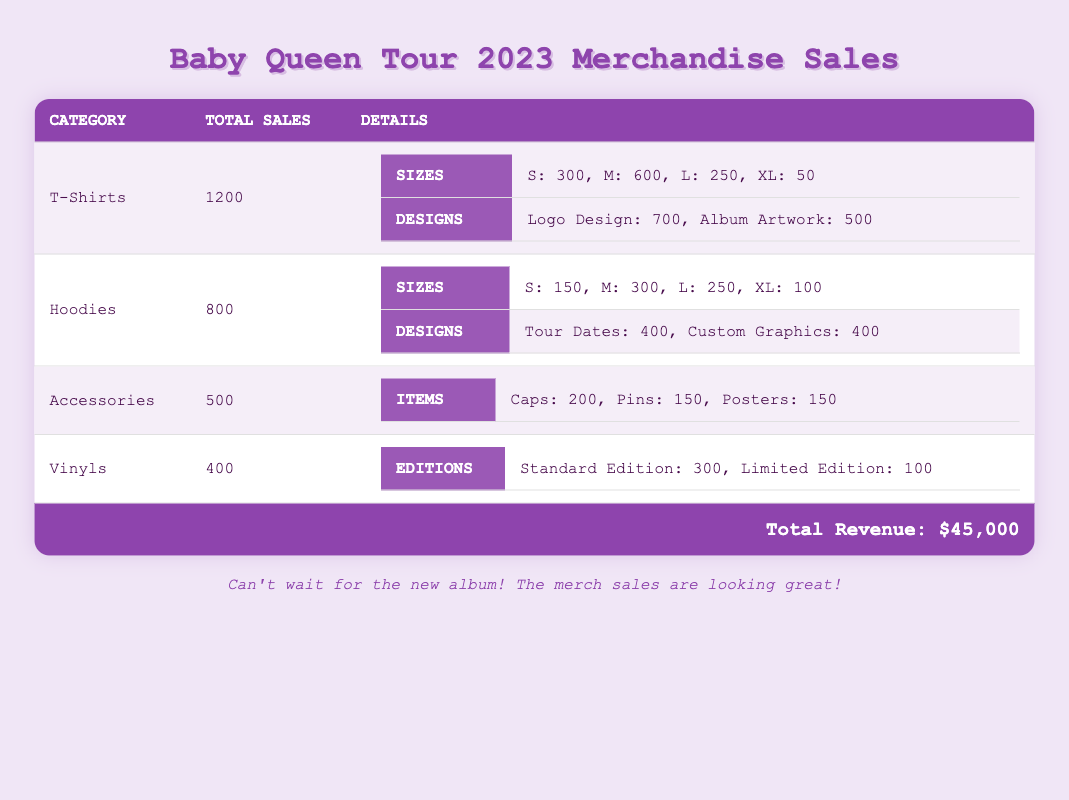What is the total number of T-Shirts sold during the Baby Queen Tour 2023? The table states that the total sales for T-Shirts is directly listed as 1200.
Answer: 1200 How many more Hoodies were sold compared to Vinyls? The total sales for Hoodies is 800 and for Vinyls is 400. The difference is calculated as 800 - 400 = 400.
Answer: 400 What size of T-Shirts had the highest sales? Looking at the breakdown of T-Shirt sizes, Medium (M) had the highest sales with 600, which is more than any other size.
Answer: Medium Is the total revenue from merchandise sales greater than $40,000? The total revenue listed is $45,000, which is indeed greater than $40,000.
Answer: Yes What is the combined number of the Custom Graphics Hoodies and the Limited Edition Vinyls sold? From the table, the number of Custom Graphics Hoodies sold is 400 and Limited Edition Vinyls is 100. Their total is 400 + 100 = 500.
Answer: 500 Which merchandise category had the least total sales? The accessories category had total sales of 500, which is less than T-Shirts (1200), Hoodies (800), and Vinyls (400).
Answer: Accessories What percentage of the total T-Shirts sold were in size Large? Large size sales are 250 T-Shirts. To find the percentage, calculate (250 / 1200) * 100 = 20.83%.
Answer: 20.83% How many Caps, Pins, and Posters are included in the Accessories category? The table shows Caps at 200, Pins at 150, and Posters at 150. The total is 200 + 150 + 150 = 500.
Answer: 500 How many more Logo Design T-Shirts were sold compared to Tour Dates Hoodies? The sales for Logo Design T-Shirts is 700, and for Tour Dates Hoodies it is 400. The difference is 700 - 400 = 300.
Answer: 300 